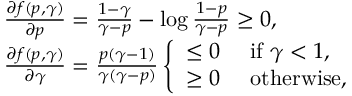<formula> <loc_0><loc_0><loc_500><loc_500>\begin{array} { r l } & { \frac { \partial { f ( p , \gamma ) } } { \partial { p } } = \frac { 1 - \gamma } { \gamma - p } - \log \frac { 1 - p } { \gamma - p } \geq 0 , } \\ & { \frac { \partial { f ( p , \gamma ) } } { \partial { \gamma } } = \frac { p ( \gamma - 1 ) } { \gamma ( \gamma - p ) } \left \{ \begin{array} { l l } { \leq 0 } & { \ i f \ \gamma < 1 , } \\ { \geq 0 } & { \ o t h e r w i s e , } \end{array} } \end{array}</formula> 